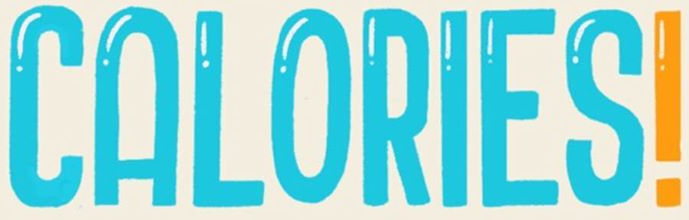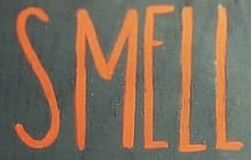What words can you see in these images in sequence, separated by a semicolon? CALORIES!; SMELL 